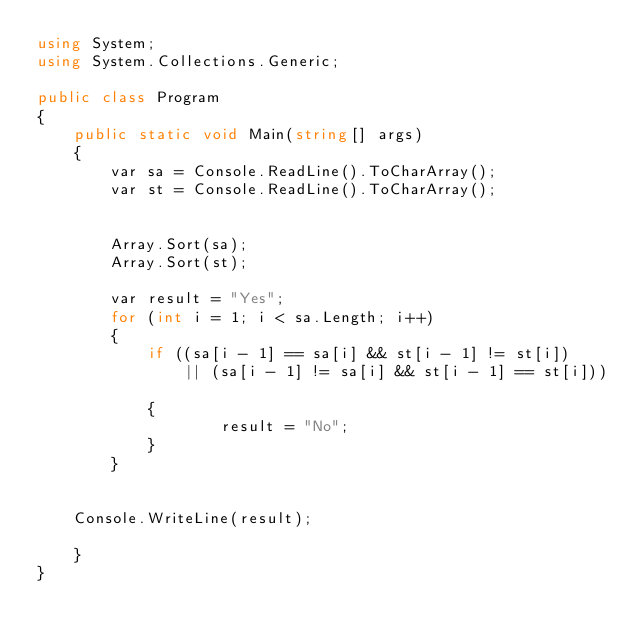Convert code to text. <code><loc_0><loc_0><loc_500><loc_500><_C#_>using System;
using System.Collections.Generic;

public class Program
{
    public static void Main(string[] args)
    {
        var sa = Console.ReadLine().ToCharArray();
        var st = Console.ReadLine().ToCharArray();


        Array.Sort(sa);
        Array.Sort(st);

        var result = "Yes";
        for (int i = 1; i < sa.Length; i++)
        {
            if ((sa[i - 1] == sa[i] && st[i - 1] != st[i]) 
                || (sa[i - 1] != sa[i] && st[i - 1] == st[i]))

            {
                    result = "No";
            }
        }
    

    Console.WriteLine(result);

    }
}</code> 